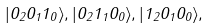<formula> <loc_0><loc_0><loc_500><loc_500>| 0 _ { 2 } 0 _ { 1 } 1 _ { 0 } \rangle , | 0 _ { 2 } 1 _ { 1 } 0 _ { 0 } \rangle , | 1 _ { 2 } 0 _ { 1 } 0 _ { 0 } \rangle ,</formula> 